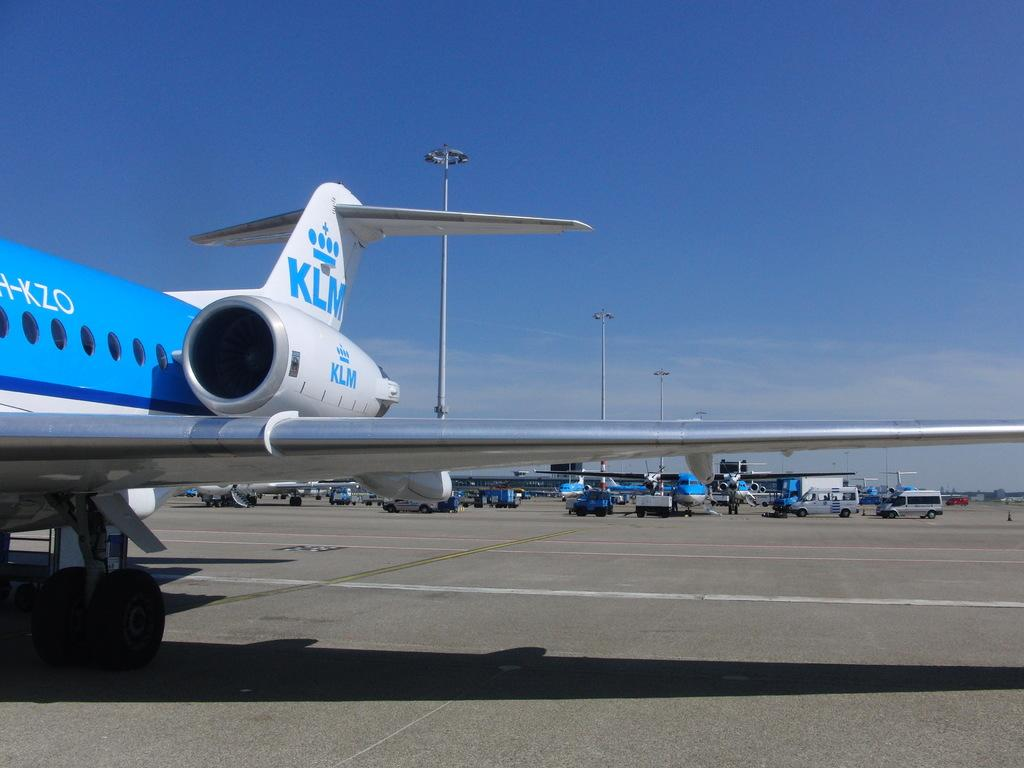What is the main subject of the image? The main subject of the image is a flight. What can be seen in the background of the image? There are many vehicles and light poles in the background. What is visible in the sky in the image? The sky with clouds is visible in the background. What type of stamp can be seen on the flight in the image? There is no stamp present on the flight; it is a representation of a flight in motion. 